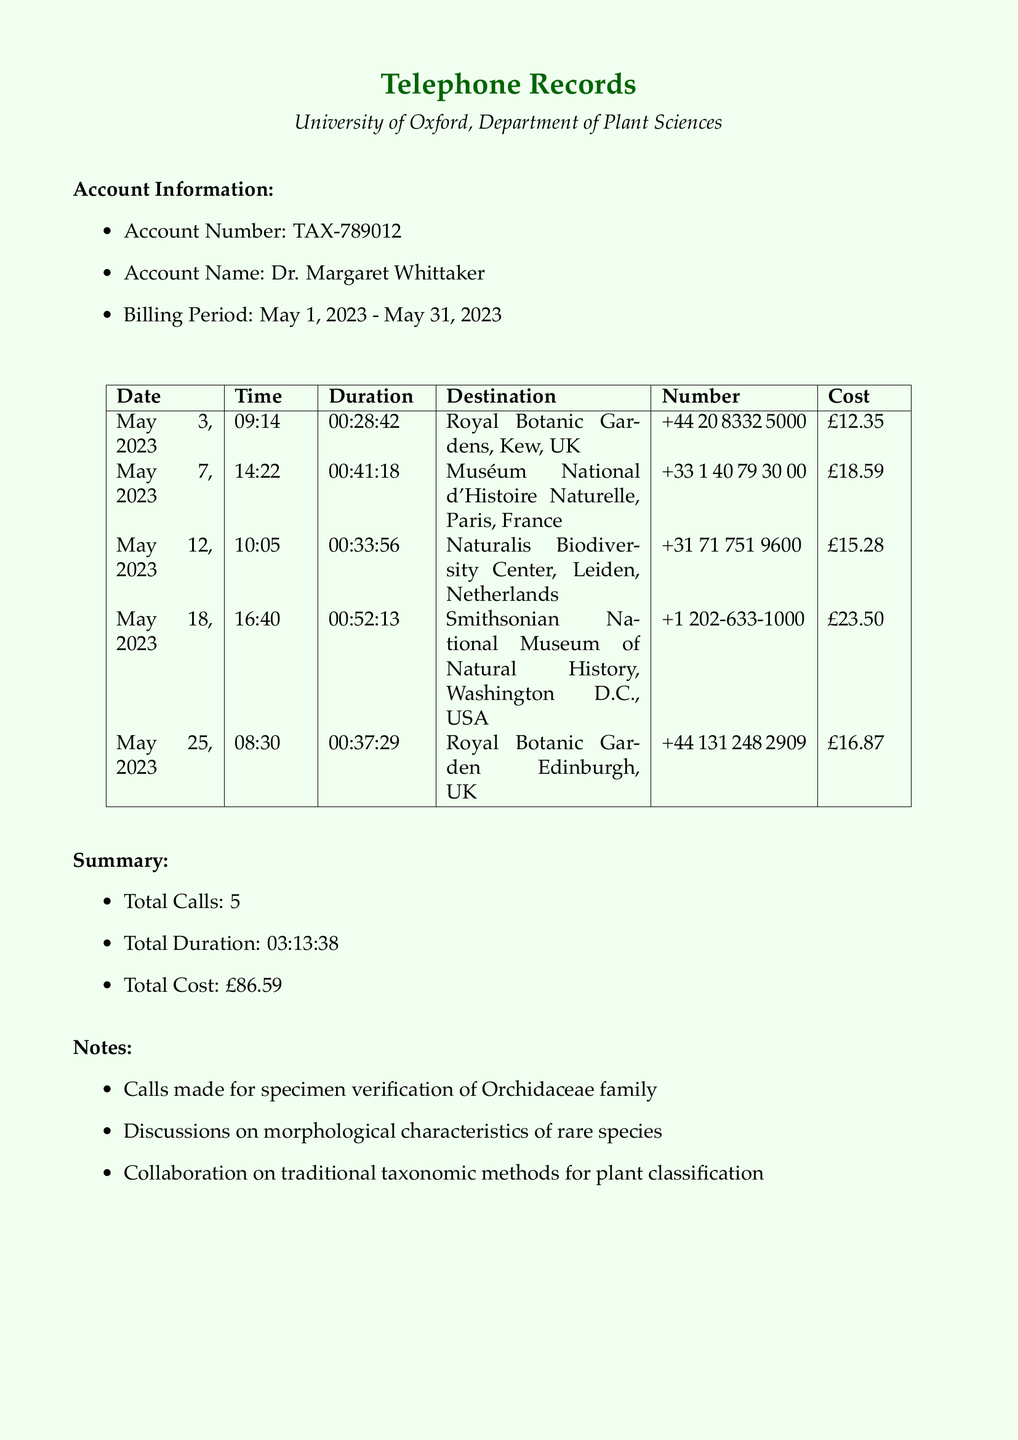what is the account number? The account number is stated in the account information section of the document.
Answer: TAX-789012 what is the billing period? The billing period is mentioned in the account information section, indicating the duration of the billing.
Answer: May 1, 2023 - May 31, 2023 how many total calls were made? The total number of calls is summarized in the summary section of the document.
Answer: 5 what is the total cost of the calls? The total cost is provided in the summary section, which is the sum of all individual call costs.
Answer: £86.59 which institution was called on May 12, 2023? The specific date and corresponding destination can be found in the table of call records.
Answer: Naturalis Biodiversity Center, Leiden, Netherlands what was the duration of the call to the Smithsonian National Museum of Natural History? The duration of each call is listed in the corresponding row for each call in the table.
Answer: 00:52:13 what is the purpose of the calls according to the notes? The purpose is summarized in the notes section where specific activities related to the calls are mentioned.
Answer: Specimen verification of Orchidaceae family which country is the Muséum National d'Histoire Naturelle located in? The country is inferred from the destination name and is explicitly stated in the call details.
Answer: France what was the cost of the call to the Royal Botanic Garden Edinburgh? The cost for each call is detailed in the table of call records.
Answer: £16.87 